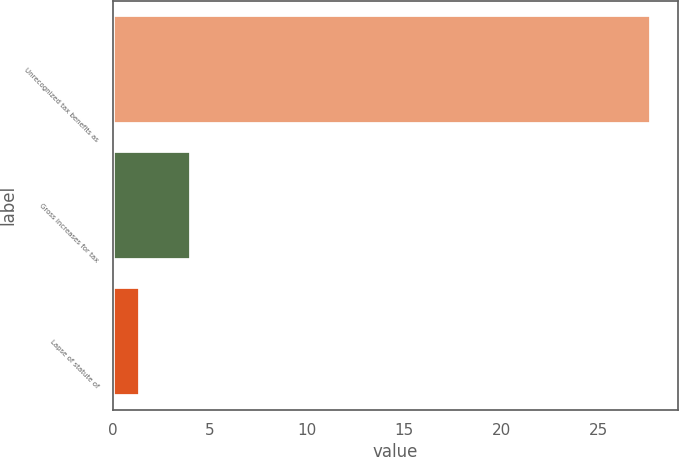<chart> <loc_0><loc_0><loc_500><loc_500><bar_chart><fcel>Unrecognized tax benefits as<fcel>Gross increases for tax<fcel>Lapse of statute of<nl><fcel>27.7<fcel>4.03<fcel>1.4<nl></chart> 